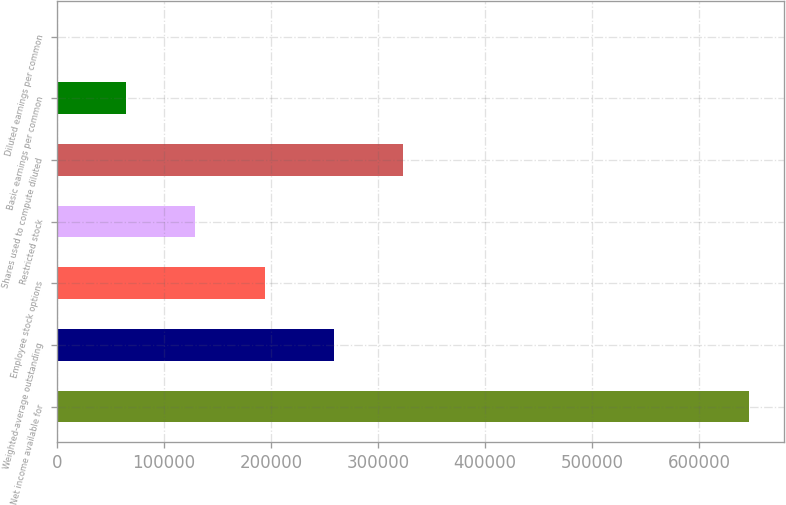Convert chart to OTSL. <chart><loc_0><loc_0><loc_500><loc_500><bar_chart><fcel>Net income available for<fcel>Weighted-average outstanding<fcel>Employee stock options<fcel>Restricted stock<fcel>Shares used to compute diluted<fcel>Basic earnings per common<fcel>Diluted earnings per common<nl><fcel>647154<fcel>258864<fcel>194149<fcel>129434<fcel>323579<fcel>64718.8<fcel>3.83<nl></chart> 